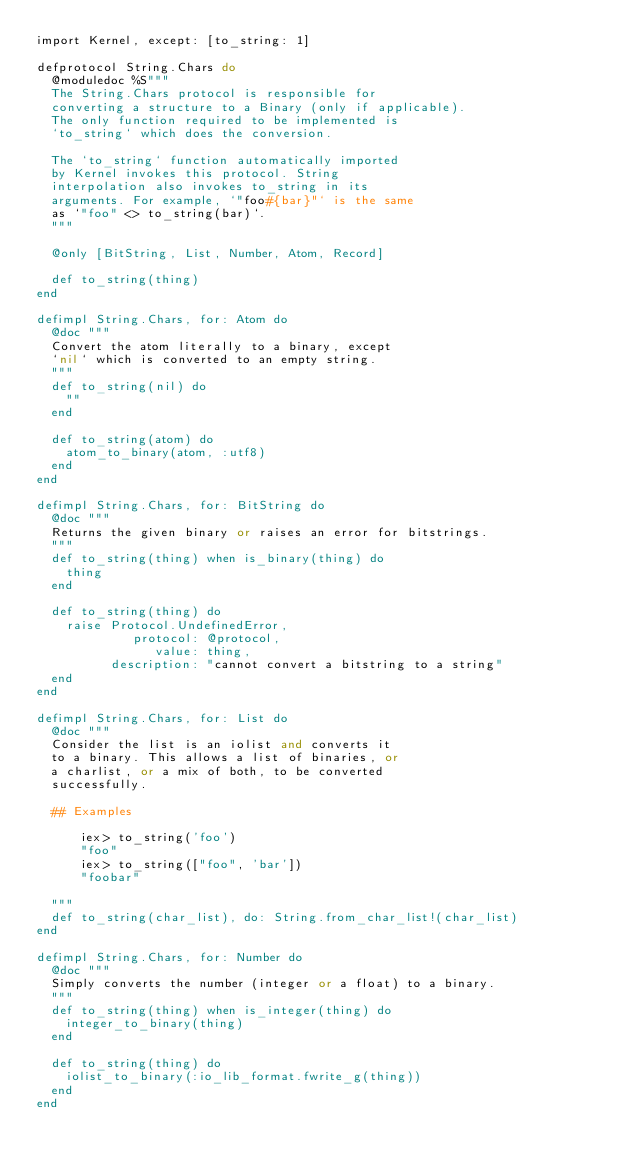<code> <loc_0><loc_0><loc_500><loc_500><_Elixir_>import Kernel, except: [to_string: 1]

defprotocol String.Chars do
  @moduledoc %S"""
  The String.Chars protocol is responsible for
  converting a structure to a Binary (only if applicable).
  The only function required to be implemented is
  `to_string` which does the conversion.

  The `to_string` function automatically imported
  by Kernel invokes this protocol. String
  interpolation also invokes to_string in its
  arguments. For example, `"foo#{bar}"` is the same
  as `"foo" <> to_string(bar)`.
  """

  @only [BitString, List, Number, Atom, Record]

  def to_string(thing)
end

defimpl String.Chars, for: Atom do
  @doc """
  Convert the atom literally to a binary, except
  `nil` which is converted to an empty string.
  """
  def to_string(nil) do
    ""
  end

  def to_string(atom) do
    atom_to_binary(atom, :utf8)
  end
end

defimpl String.Chars, for: BitString do
  @doc """
  Returns the given binary or raises an error for bitstrings.
  """
  def to_string(thing) when is_binary(thing) do
    thing
  end

  def to_string(thing) do
    raise Protocol.UndefinedError,
             protocol: @protocol,
                value: thing,
          description: "cannot convert a bitstring to a string"
  end
end

defimpl String.Chars, for: List do
  @doc """
  Consider the list is an iolist and converts it
  to a binary. This allows a list of binaries, or
  a charlist, or a mix of both, to be converted
  successfully.

  ## Examples

      iex> to_string('foo')
      "foo"
      iex> to_string(["foo", 'bar'])
      "foobar"

  """
  def to_string(char_list), do: String.from_char_list!(char_list)
end

defimpl String.Chars, for: Number do
  @doc """
  Simply converts the number (integer or a float) to a binary.
  """
  def to_string(thing) when is_integer(thing) do
    integer_to_binary(thing)
  end

  def to_string(thing) do
    iolist_to_binary(:io_lib_format.fwrite_g(thing))
  end
end
</code> 